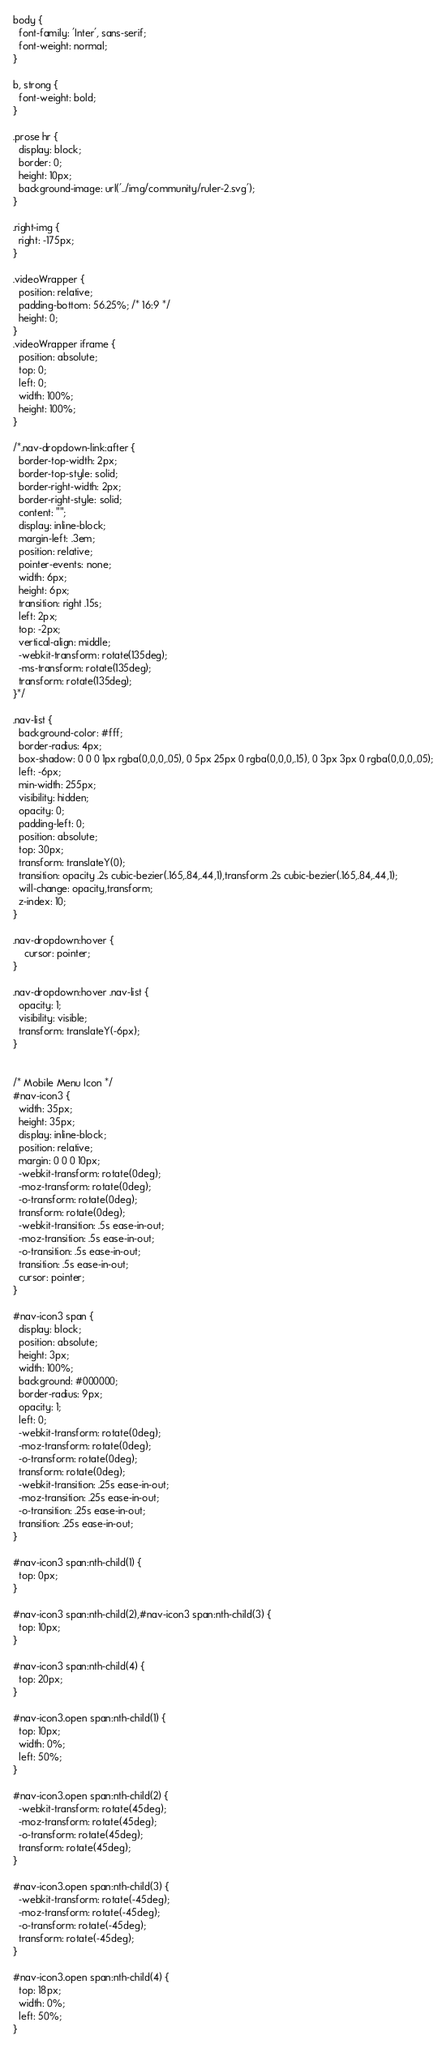Convert code to text. <code><loc_0><loc_0><loc_500><loc_500><_CSS_>body {
  font-family: 'Inter', sans-serif;
  font-weight: normal;
}

b, strong {
  font-weight: bold;
}

.prose hr {
  display: block;
  border: 0;
  height: 10px;
  background-image: url('../img/community/ruler-2.svg');
}

.right-img {
  right: -175px;
}

.videoWrapper {
  position: relative;
  padding-bottom: 56.25%; /* 16:9 */
  height: 0;
}
.videoWrapper iframe {
  position: absolute;
  top: 0;
  left: 0;
  width: 100%;
  height: 100%;
}

/*.nav-dropdown-link:after {
  border-top-width: 2px;
  border-top-style: solid;
  border-right-width: 2px;
  border-right-style: solid;
  content: "";
  display: inline-block;
  margin-left: .3em;
  position: relative;
  pointer-events: none;
  width: 6px;
  height: 6px;
  transition: right .15s;
  left: 2px;
  top: -2px;
  vertical-align: middle;
  -webkit-transform: rotate(135deg);
  -ms-transform: rotate(135deg);
  transform: rotate(135deg);
}*/

.nav-list {
  background-color: #fff;
  border-radius: 4px;
  box-shadow: 0 0 0 1px rgba(0,0,0,.05), 0 5px 25px 0 rgba(0,0,0,.15), 0 3px 3px 0 rgba(0,0,0,.05);
  left: -6px;
  min-width: 255px;
  visibility: hidden;
  opacity: 0;
  padding-left: 0;
  position: absolute;
  top: 30px;
  transform: translateY(0);
  transition: opacity .2s cubic-bezier(.165,.84,.44,1),transform .2s cubic-bezier(.165,.84,.44,1);
  will-change: opacity,transform;
  z-index: 10;
}

.nav-dropdown:hover {
	cursor: pointer;
}

.nav-dropdown:hover .nav-list {
  opacity: 1;
  visibility: visible;
  transform: translateY(-6px);
}


/* Mobile Menu Icon */
#nav-icon3 {
  width: 35px;
  height: 35px;
  display: inline-block;
  position: relative;
  margin: 0 0 0 10px;
  -webkit-transform: rotate(0deg);
  -moz-transform: rotate(0deg);
  -o-transform: rotate(0deg);
  transform: rotate(0deg);
  -webkit-transition: .5s ease-in-out;
  -moz-transition: .5s ease-in-out;
  -o-transition: .5s ease-in-out;
  transition: .5s ease-in-out;
  cursor: pointer;
}

#nav-icon3 span {
  display: block;
  position: absolute;
  height: 3px;
  width: 100%;
  background: #000000;
  border-radius: 9px;
  opacity: 1;
  left: 0;
  -webkit-transform: rotate(0deg);
  -moz-transform: rotate(0deg);
  -o-transform: rotate(0deg);
  transform: rotate(0deg);
  -webkit-transition: .25s ease-in-out;
  -moz-transition: .25s ease-in-out;
  -o-transition: .25s ease-in-out;
  transition: .25s ease-in-out;
}

#nav-icon3 span:nth-child(1) {
  top: 0px;
}

#nav-icon3 span:nth-child(2),#nav-icon3 span:nth-child(3) {
  top: 10px;
}

#nav-icon3 span:nth-child(4) {
  top: 20px;
}

#nav-icon3.open span:nth-child(1) {
  top: 10px;
  width: 0%;
  left: 50%;
}

#nav-icon3.open span:nth-child(2) {
  -webkit-transform: rotate(45deg);
  -moz-transform: rotate(45deg);
  -o-transform: rotate(45deg);
  transform: rotate(45deg);
}

#nav-icon3.open span:nth-child(3) {
  -webkit-transform: rotate(-45deg);
  -moz-transform: rotate(-45deg);
  -o-transform: rotate(-45deg);
  transform: rotate(-45deg);
}

#nav-icon3.open span:nth-child(4) {
  top: 18px;
  width: 0%;
  left: 50%;
}</code> 